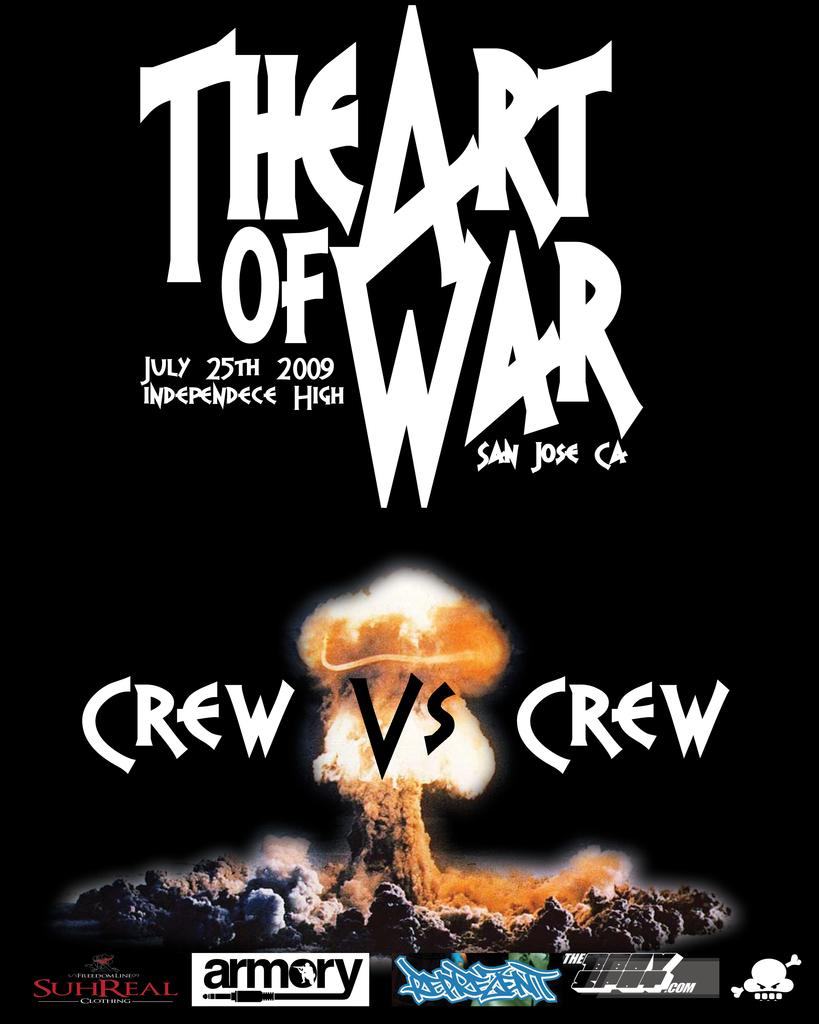<image>
Present a compact description of the photo's key features. Poster for Crew vs Crew which takes place in San Jose. 